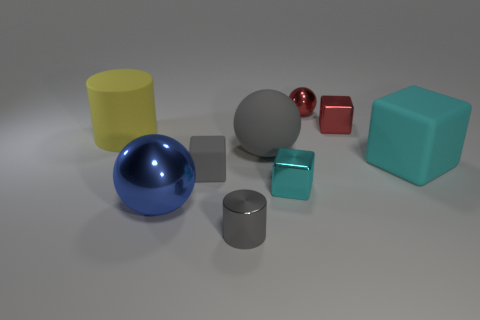Which objects in the image have a reflective surface? The objects with reflective surfaces include the small shiny cylinder, the sphere, and the cube. Their surfaces have a high gloss finish that reflects the environment. 